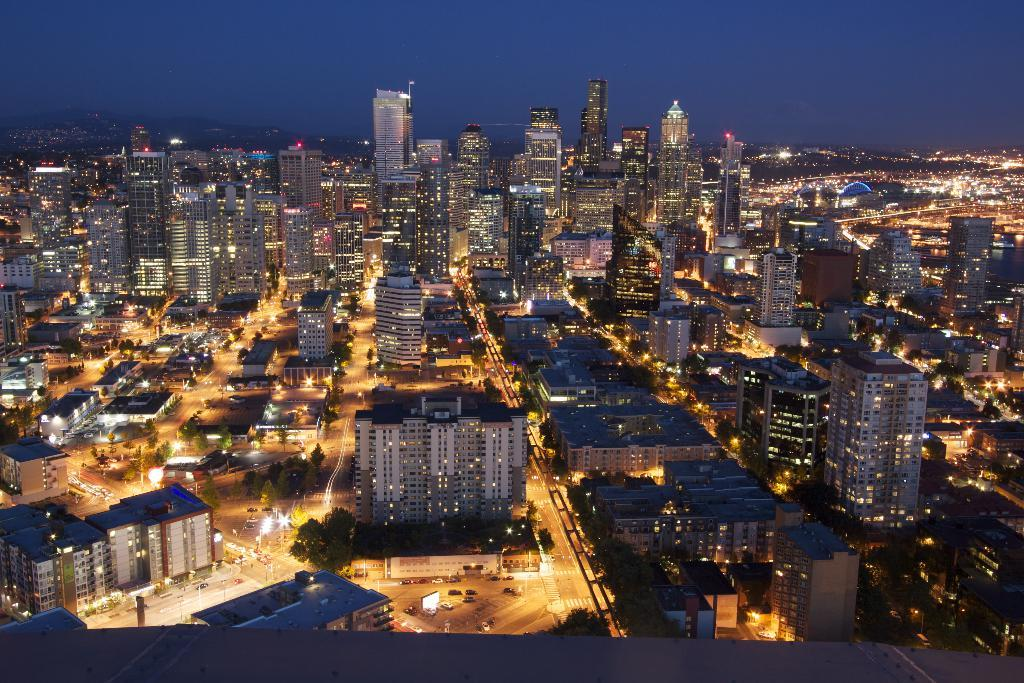What type of structures can be seen in the image? There are buildings in the image. What type of natural elements are present in the image? There are trees in the image. What type of man-made objects are visible in the image? There are vehicles in the image. What type of illumination is present in the image? There are lights in the image. What part of the natural environment is visible in the image? The sky is visible in the background of the image. Can you see the family saying good-bye in the image? There is no family or good-bye scene present in the image. Is there a cellar visible in the image? There is no cellar present in the image. 